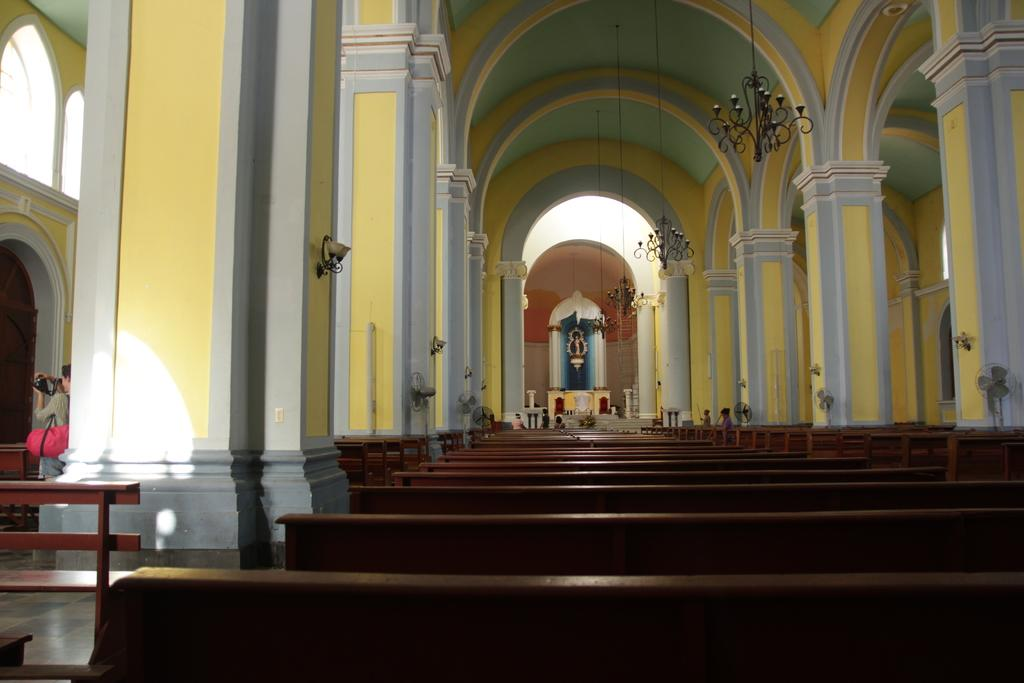What type of building can be seen in the image? There is a church in the image. What type of seating is available in the image? There are benches in the image. Can you describe the person on the left side of the image? A person is present on the left side of the image. What type of cooling device is visible on the right side of the image? There are table fans on the right side of the image. What architectural features can be seen in the image? There are pillars in the image. What type of lighting fixture is visible at the top of the image? There are chandeliers visible at the top of the image. How many cherries are hanging from the chandeliers in the image? There are no cherries present in the image; only chandeliers are visible at the top. What type of hole can be seen in the pillars in the image? There are no holes present in the pillars in the image; they are solid architectural features. 